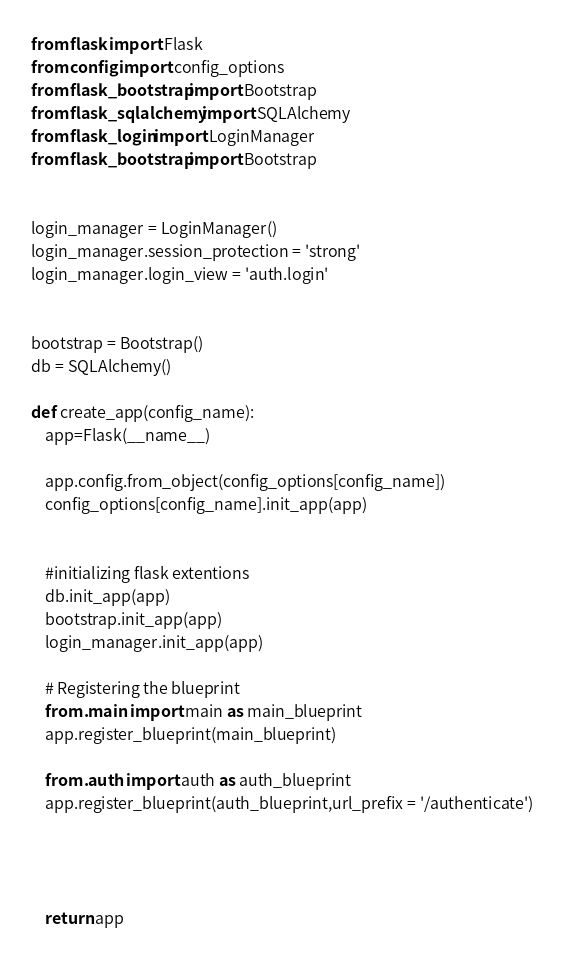Convert code to text. <code><loc_0><loc_0><loc_500><loc_500><_Python_>from flask import Flask
from config import config_options 
from flask_bootstrap import Bootstrap
from flask_sqlalchemy import SQLAlchemy
from flask_login import LoginManager
from flask_bootstrap import Bootstrap


login_manager = LoginManager()
login_manager.session_protection = 'strong'
login_manager.login_view = 'auth.login'


bootstrap = Bootstrap()
db = SQLAlchemy()

def create_app(config_name):
    app=Flask(__name__)

    app.config.from_object(config_options[config_name])
    config_options[config_name].init_app(app)


    #initializing flask extentions
    db.init_app(app)
    bootstrap.init_app(app)
    login_manager.init_app(app)

    # Registering the blueprint
    from .main import main as main_blueprint
    app.register_blueprint(main_blueprint)

    from .auth import auth as auth_blueprint
    app.register_blueprint(auth_blueprint,url_prefix = '/authenticate')

    


    return app</code> 